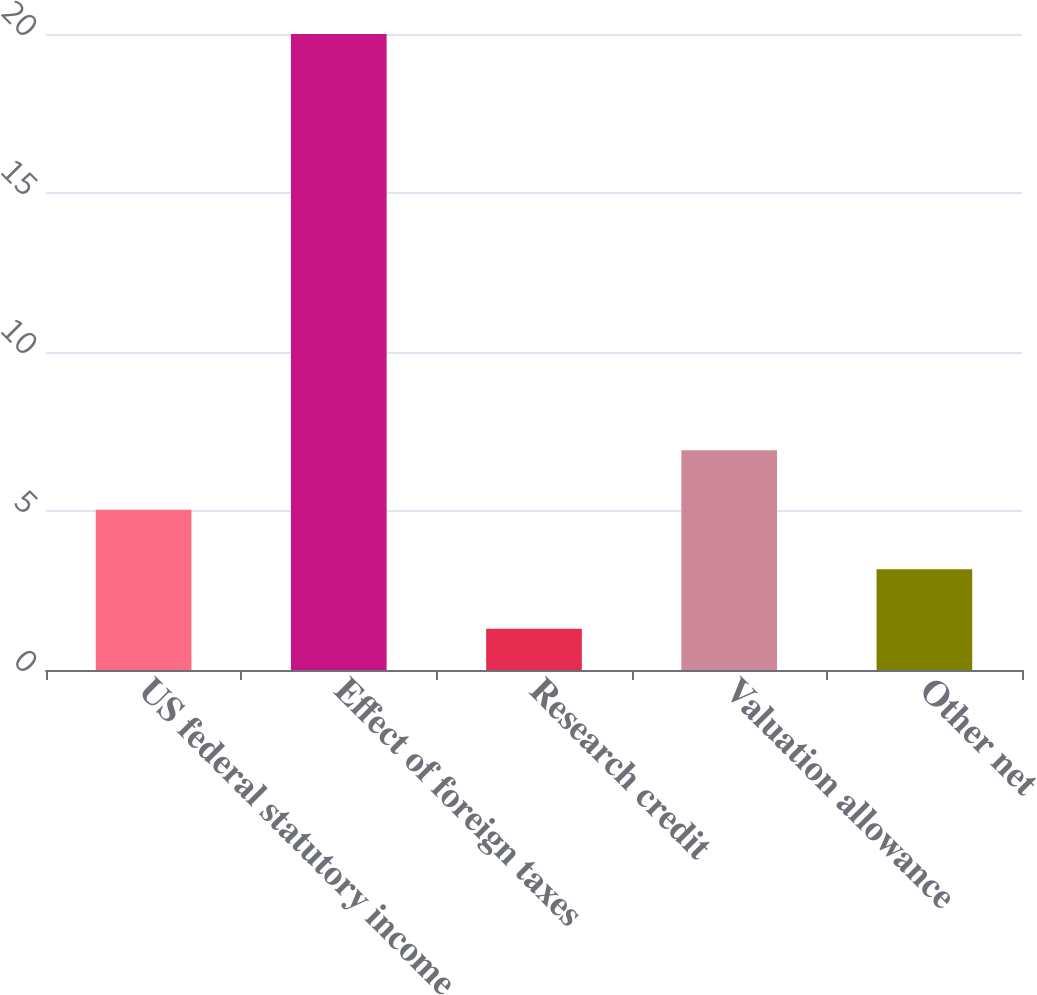<chart> <loc_0><loc_0><loc_500><loc_500><bar_chart><fcel>US federal statutory income<fcel>Effect of foreign taxes<fcel>Research credit<fcel>Valuation allowance<fcel>Other net<nl><fcel>5.04<fcel>20<fcel>1.3<fcel>6.91<fcel>3.17<nl></chart> 